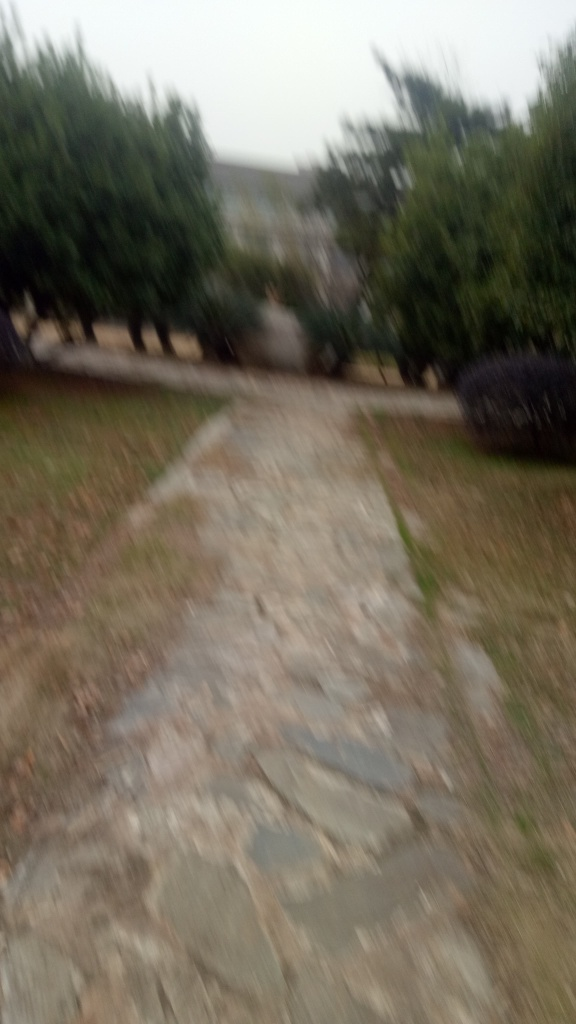What advice would you give the photographer to improve this image? To improve this image, the photographer should ensure the camera is steady when taking the photo, whether by using a tripod or a stabilizing technique. Additionally, using a faster shutter speed could help freeze any motion, and verifying focus before capturing the image would help attain a clearer result. 